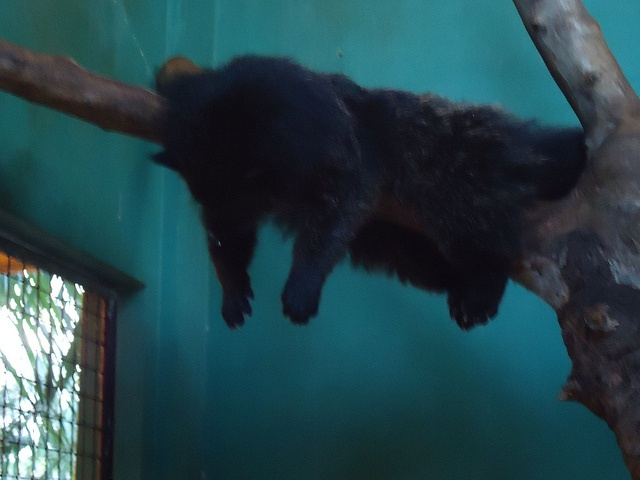Describe the objects in this image and their specific colors. I can see bear in teal, black, darkblue, and blue tones and cat in teal, black, darkblue, and blue tones in this image. 